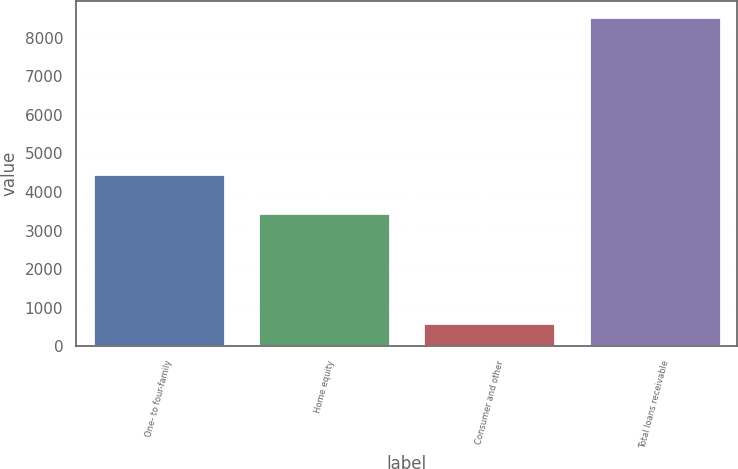Convert chart to OTSL. <chart><loc_0><loc_0><loc_500><loc_500><bar_chart><fcel>One- to four-family<fcel>Home equity<fcel>Consumer and other<fcel>Total loans receivable<nl><fcel>4475<fcel>3454<fcel>602<fcel>8531<nl></chart> 